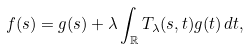Convert formula to latex. <formula><loc_0><loc_0><loc_500><loc_500>f ( s ) = g ( s ) + \lambda \int _ { \mathbb { R } } T _ { \lambda } ( s , t ) g ( t ) \, d t ,</formula> 